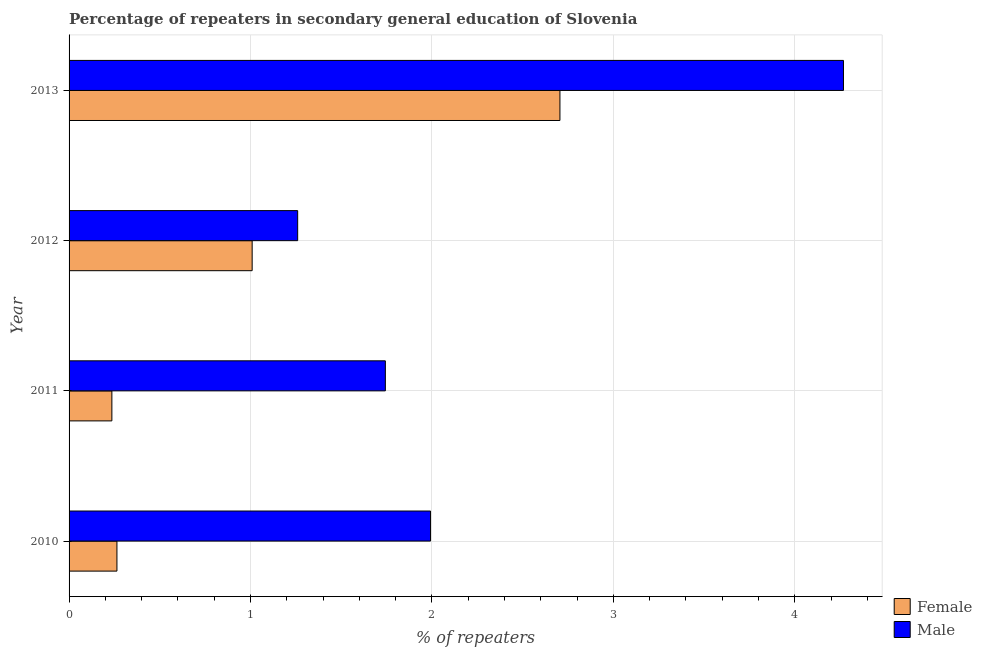How many groups of bars are there?
Keep it short and to the point. 4. Are the number of bars on each tick of the Y-axis equal?
Your answer should be compact. Yes. How many bars are there on the 3rd tick from the bottom?
Your answer should be very brief. 2. What is the percentage of male repeaters in 2013?
Your answer should be compact. 4.27. Across all years, what is the maximum percentage of female repeaters?
Give a very brief answer. 2.71. Across all years, what is the minimum percentage of male repeaters?
Your response must be concise. 1.26. In which year was the percentage of female repeaters maximum?
Your response must be concise. 2013. What is the total percentage of female repeaters in the graph?
Your answer should be very brief. 4.21. What is the difference between the percentage of male repeaters in 2011 and that in 2012?
Your response must be concise. 0.48. What is the difference between the percentage of male repeaters in 2010 and the percentage of female repeaters in 2011?
Your answer should be compact. 1.76. What is the average percentage of male repeaters per year?
Provide a short and direct response. 2.32. In the year 2013, what is the difference between the percentage of male repeaters and percentage of female repeaters?
Offer a very short reply. 1.56. What is the ratio of the percentage of female repeaters in 2010 to that in 2012?
Your answer should be compact. 0.26. Is the percentage of female repeaters in 2010 less than that in 2012?
Offer a terse response. Yes. Is the difference between the percentage of male repeaters in 2011 and 2012 greater than the difference between the percentage of female repeaters in 2011 and 2012?
Your answer should be compact. Yes. What is the difference between the highest and the second highest percentage of female repeaters?
Your response must be concise. 1.7. What is the difference between the highest and the lowest percentage of female repeaters?
Provide a succinct answer. 2.47. In how many years, is the percentage of female repeaters greater than the average percentage of female repeaters taken over all years?
Offer a very short reply. 1. Is the sum of the percentage of male repeaters in 2010 and 2011 greater than the maximum percentage of female repeaters across all years?
Ensure brevity in your answer.  Yes. What does the 1st bar from the bottom in 2010 represents?
Make the answer very short. Female. How many bars are there?
Offer a terse response. 8. How many years are there in the graph?
Your answer should be compact. 4. What is the difference between two consecutive major ticks on the X-axis?
Keep it short and to the point. 1. Are the values on the major ticks of X-axis written in scientific E-notation?
Provide a succinct answer. No. Does the graph contain any zero values?
Make the answer very short. No. Does the graph contain grids?
Provide a short and direct response. Yes. What is the title of the graph?
Make the answer very short. Percentage of repeaters in secondary general education of Slovenia. Does "From Government" appear as one of the legend labels in the graph?
Ensure brevity in your answer.  No. What is the label or title of the X-axis?
Provide a short and direct response. % of repeaters. What is the label or title of the Y-axis?
Offer a very short reply. Year. What is the % of repeaters of Female in 2010?
Provide a short and direct response. 0.26. What is the % of repeaters of Male in 2010?
Your response must be concise. 1.99. What is the % of repeaters in Female in 2011?
Your answer should be compact. 0.24. What is the % of repeaters in Male in 2011?
Ensure brevity in your answer.  1.74. What is the % of repeaters of Female in 2012?
Offer a terse response. 1.01. What is the % of repeaters in Male in 2012?
Give a very brief answer. 1.26. What is the % of repeaters in Female in 2013?
Provide a succinct answer. 2.71. What is the % of repeaters of Male in 2013?
Your answer should be very brief. 4.27. Across all years, what is the maximum % of repeaters of Female?
Offer a terse response. 2.71. Across all years, what is the maximum % of repeaters in Male?
Provide a short and direct response. 4.27. Across all years, what is the minimum % of repeaters in Female?
Make the answer very short. 0.24. Across all years, what is the minimum % of repeaters of Male?
Your answer should be compact. 1.26. What is the total % of repeaters in Female in the graph?
Ensure brevity in your answer.  4.21. What is the total % of repeaters of Male in the graph?
Your answer should be compact. 9.26. What is the difference between the % of repeaters in Female in 2010 and that in 2011?
Offer a terse response. 0.03. What is the difference between the % of repeaters of Male in 2010 and that in 2011?
Give a very brief answer. 0.25. What is the difference between the % of repeaters of Female in 2010 and that in 2012?
Your answer should be very brief. -0.75. What is the difference between the % of repeaters of Male in 2010 and that in 2012?
Your response must be concise. 0.73. What is the difference between the % of repeaters in Female in 2010 and that in 2013?
Give a very brief answer. -2.44. What is the difference between the % of repeaters of Male in 2010 and that in 2013?
Your answer should be very brief. -2.28. What is the difference between the % of repeaters of Female in 2011 and that in 2012?
Keep it short and to the point. -0.77. What is the difference between the % of repeaters in Male in 2011 and that in 2012?
Your answer should be compact. 0.48. What is the difference between the % of repeaters of Female in 2011 and that in 2013?
Offer a very short reply. -2.47. What is the difference between the % of repeaters of Male in 2011 and that in 2013?
Provide a succinct answer. -2.53. What is the difference between the % of repeaters in Female in 2012 and that in 2013?
Your response must be concise. -1.7. What is the difference between the % of repeaters in Male in 2012 and that in 2013?
Ensure brevity in your answer.  -3.01. What is the difference between the % of repeaters of Female in 2010 and the % of repeaters of Male in 2011?
Ensure brevity in your answer.  -1.48. What is the difference between the % of repeaters of Female in 2010 and the % of repeaters of Male in 2012?
Your answer should be very brief. -1. What is the difference between the % of repeaters in Female in 2010 and the % of repeaters in Male in 2013?
Your answer should be very brief. -4. What is the difference between the % of repeaters of Female in 2011 and the % of repeaters of Male in 2012?
Provide a succinct answer. -1.02. What is the difference between the % of repeaters in Female in 2011 and the % of repeaters in Male in 2013?
Ensure brevity in your answer.  -4.03. What is the difference between the % of repeaters in Female in 2012 and the % of repeaters in Male in 2013?
Make the answer very short. -3.26. What is the average % of repeaters in Female per year?
Make the answer very short. 1.05. What is the average % of repeaters of Male per year?
Give a very brief answer. 2.32. In the year 2010, what is the difference between the % of repeaters of Female and % of repeaters of Male?
Provide a succinct answer. -1.73. In the year 2011, what is the difference between the % of repeaters of Female and % of repeaters of Male?
Offer a very short reply. -1.51. In the year 2012, what is the difference between the % of repeaters of Female and % of repeaters of Male?
Offer a terse response. -0.25. In the year 2013, what is the difference between the % of repeaters of Female and % of repeaters of Male?
Provide a succinct answer. -1.56. What is the ratio of the % of repeaters of Female in 2010 to that in 2011?
Offer a very short reply. 1.12. What is the ratio of the % of repeaters of Male in 2010 to that in 2011?
Provide a short and direct response. 1.14. What is the ratio of the % of repeaters in Female in 2010 to that in 2012?
Your response must be concise. 0.26. What is the ratio of the % of repeaters in Male in 2010 to that in 2012?
Your response must be concise. 1.58. What is the ratio of the % of repeaters of Female in 2010 to that in 2013?
Give a very brief answer. 0.1. What is the ratio of the % of repeaters in Male in 2010 to that in 2013?
Offer a terse response. 0.47. What is the ratio of the % of repeaters of Female in 2011 to that in 2012?
Offer a terse response. 0.23. What is the ratio of the % of repeaters of Male in 2011 to that in 2012?
Make the answer very short. 1.38. What is the ratio of the % of repeaters of Female in 2011 to that in 2013?
Give a very brief answer. 0.09. What is the ratio of the % of repeaters of Male in 2011 to that in 2013?
Your answer should be compact. 0.41. What is the ratio of the % of repeaters in Female in 2012 to that in 2013?
Offer a terse response. 0.37. What is the ratio of the % of repeaters in Male in 2012 to that in 2013?
Your answer should be very brief. 0.3. What is the difference between the highest and the second highest % of repeaters in Female?
Ensure brevity in your answer.  1.7. What is the difference between the highest and the second highest % of repeaters of Male?
Give a very brief answer. 2.28. What is the difference between the highest and the lowest % of repeaters of Female?
Offer a terse response. 2.47. What is the difference between the highest and the lowest % of repeaters of Male?
Your answer should be very brief. 3.01. 